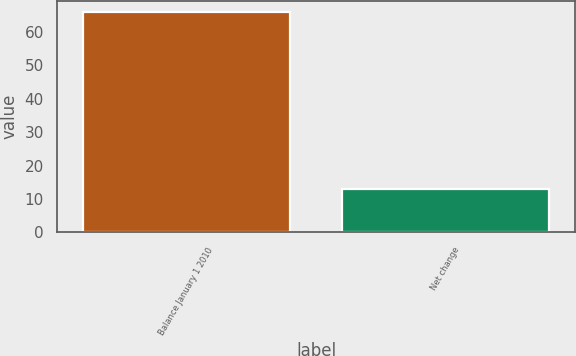Convert chart to OTSL. <chart><loc_0><loc_0><loc_500><loc_500><bar_chart><fcel>Balance January 1 2010<fcel>Net change<nl><fcel>66<fcel>13<nl></chart> 